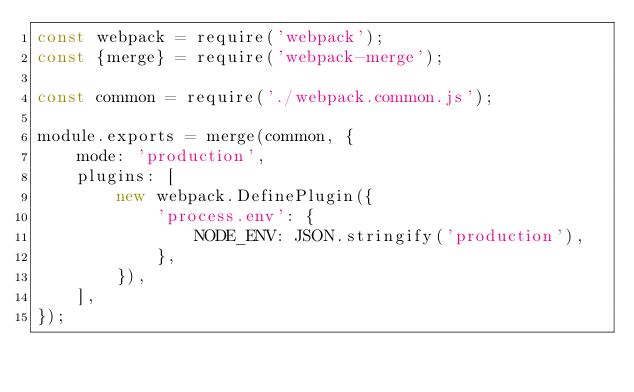<code> <loc_0><loc_0><loc_500><loc_500><_JavaScript_>const webpack = require('webpack');
const {merge} = require('webpack-merge');

const common = require('./webpack.common.js');

module.exports = merge(common, {
    mode: 'production',
    plugins: [
        new webpack.DefinePlugin({
            'process.env': {
                NODE_ENV: JSON.stringify('production'),
            },
        }),
    ],
});
</code> 